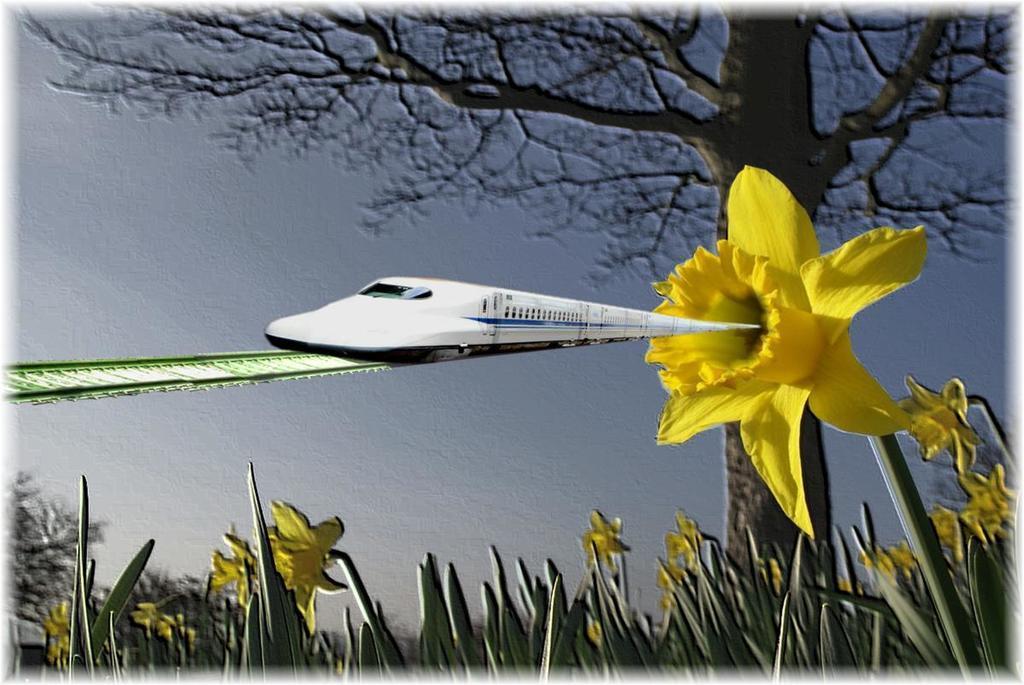Please provide a concise description of this image. It is an edited image, at the bottom there are yellow color flowers, on the right side there is a tree. In the middle a train is moving on the railway track and this is the sky. 